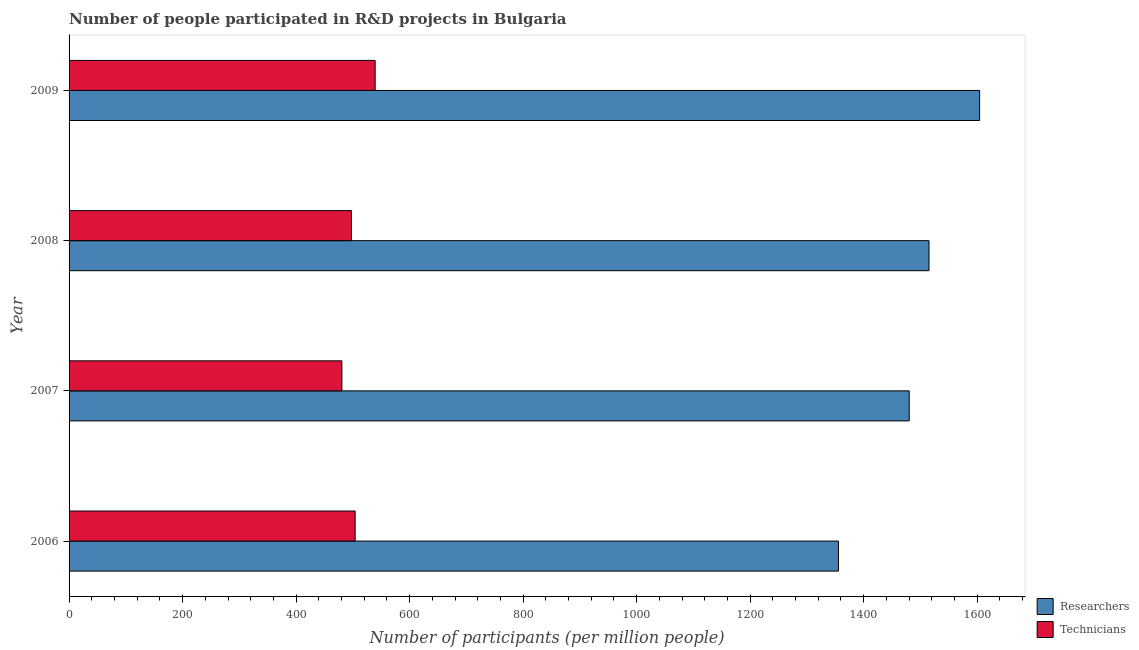Are the number of bars on each tick of the Y-axis equal?
Provide a succinct answer. Yes. How many bars are there on the 3rd tick from the bottom?
Provide a succinct answer. 2. In how many cases, is the number of bars for a given year not equal to the number of legend labels?
Your answer should be very brief. 0. What is the number of researchers in 2009?
Give a very brief answer. 1604.28. Across all years, what is the maximum number of technicians?
Ensure brevity in your answer.  539.27. Across all years, what is the minimum number of researchers?
Make the answer very short. 1355.61. In which year was the number of technicians minimum?
Provide a succinct answer. 2007. What is the total number of researchers in the graph?
Give a very brief answer. 5955.24. What is the difference between the number of technicians in 2006 and that in 2007?
Your answer should be very brief. 23.34. What is the difference between the number of researchers in 2009 and the number of technicians in 2008?
Offer a very short reply. 1106.78. What is the average number of technicians per year?
Ensure brevity in your answer.  505.37. In the year 2007, what is the difference between the number of technicians and number of researchers?
Your response must be concise. -999.55. In how many years, is the number of researchers greater than 400 ?
Keep it short and to the point. 4. What is the ratio of the number of researchers in 2006 to that in 2009?
Your answer should be very brief. 0.84. Is the number of technicians in 2006 less than that in 2007?
Provide a succinct answer. No. What is the difference between the highest and the second highest number of technicians?
Your response must be concise. 35.25. What is the difference between the highest and the lowest number of technicians?
Your answer should be very brief. 58.59. What does the 2nd bar from the top in 2006 represents?
Make the answer very short. Researchers. What does the 2nd bar from the bottom in 2007 represents?
Give a very brief answer. Technicians. Are all the bars in the graph horizontal?
Provide a short and direct response. Yes. How many years are there in the graph?
Keep it short and to the point. 4. Does the graph contain grids?
Your answer should be very brief. No. How many legend labels are there?
Your response must be concise. 2. What is the title of the graph?
Offer a very short reply. Number of people participated in R&D projects in Bulgaria. Does "2012 US$" appear as one of the legend labels in the graph?
Provide a succinct answer. No. What is the label or title of the X-axis?
Give a very brief answer. Number of participants (per million people). What is the label or title of the Y-axis?
Provide a succinct answer. Year. What is the Number of participants (per million people) of Researchers in 2006?
Ensure brevity in your answer.  1355.61. What is the Number of participants (per million people) of Technicians in 2006?
Your response must be concise. 504.03. What is the Number of participants (per million people) in Researchers in 2007?
Provide a short and direct response. 1480.24. What is the Number of participants (per million people) in Technicians in 2007?
Offer a very short reply. 480.68. What is the Number of participants (per million people) of Researchers in 2008?
Offer a very short reply. 1515.11. What is the Number of participants (per million people) of Technicians in 2008?
Provide a succinct answer. 497.49. What is the Number of participants (per million people) of Researchers in 2009?
Make the answer very short. 1604.28. What is the Number of participants (per million people) of Technicians in 2009?
Ensure brevity in your answer.  539.27. Across all years, what is the maximum Number of participants (per million people) in Researchers?
Ensure brevity in your answer.  1604.28. Across all years, what is the maximum Number of participants (per million people) in Technicians?
Keep it short and to the point. 539.27. Across all years, what is the minimum Number of participants (per million people) of Researchers?
Give a very brief answer. 1355.61. Across all years, what is the minimum Number of participants (per million people) in Technicians?
Make the answer very short. 480.68. What is the total Number of participants (per million people) of Researchers in the graph?
Give a very brief answer. 5955.24. What is the total Number of participants (per million people) of Technicians in the graph?
Offer a very short reply. 2021.48. What is the difference between the Number of participants (per million people) in Researchers in 2006 and that in 2007?
Ensure brevity in your answer.  -124.63. What is the difference between the Number of participants (per million people) in Technicians in 2006 and that in 2007?
Give a very brief answer. 23.34. What is the difference between the Number of participants (per million people) in Researchers in 2006 and that in 2008?
Give a very brief answer. -159.5. What is the difference between the Number of participants (per million people) of Technicians in 2006 and that in 2008?
Provide a succinct answer. 6.53. What is the difference between the Number of participants (per million people) of Researchers in 2006 and that in 2009?
Your response must be concise. -248.67. What is the difference between the Number of participants (per million people) in Technicians in 2006 and that in 2009?
Your response must be concise. -35.25. What is the difference between the Number of participants (per million people) in Researchers in 2007 and that in 2008?
Provide a short and direct response. -34.87. What is the difference between the Number of participants (per million people) of Technicians in 2007 and that in 2008?
Ensure brevity in your answer.  -16.81. What is the difference between the Number of participants (per million people) in Researchers in 2007 and that in 2009?
Keep it short and to the point. -124.04. What is the difference between the Number of participants (per million people) of Technicians in 2007 and that in 2009?
Provide a short and direct response. -58.59. What is the difference between the Number of participants (per million people) in Researchers in 2008 and that in 2009?
Offer a very short reply. -89.17. What is the difference between the Number of participants (per million people) of Technicians in 2008 and that in 2009?
Your answer should be compact. -41.78. What is the difference between the Number of participants (per million people) in Researchers in 2006 and the Number of participants (per million people) in Technicians in 2007?
Your response must be concise. 874.93. What is the difference between the Number of participants (per million people) in Researchers in 2006 and the Number of participants (per million people) in Technicians in 2008?
Offer a terse response. 858.12. What is the difference between the Number of participants (per million people) in Researchers in 2006 and the Number of participants (per million people) in Technicians in 2009?
Give a very brief answer. 816.34. What is the difference between the Number of participants (per million people) in Researchers in 2007 and the Number of participants (per million people) in Technicians in 2008?
Your answer should be very brief. 982.74. What is the difference between the Number of participants (per million people) in Researchers in 2007 and the Number of participants (per million people) in Technicians in 2009?
Provide a succinct answer. 940.97. What is the difference between the Number of participants (per million people) of Researchers in 2008 and the Number of participants (per million people) of Technicians in 2009?
Offer a very short reply. 975.84. What is the average Number of participants (per million people) of Researchers per year?
Your response must be concise. 1488.81. What is the average Number of participants (per million people) of Technicians per year?
Your answer should be compact. 505.37. In the year 2006, what is the difference between the Number of participants (per million people) in Researchers and Number of participants (per million people) in Technicians?
Offer a very short reply. 851.58. In the year 2007, what is the difference between the Number of participants (per million people) in Researchers and Number of participants (per million people) in Technicians?
Offer a terse response. 999.55. In the year 2008, what is the difference between the Number of participants (per million people) in Researchers and Number of participants (per million people) in Technicians?
Offer a very short reply. 1017.62. In the year 2009, what is the difference between the Number of participants (per million people) of Researchers and Number of participants (per million people) of Technicians?
Provide a succinct answer. 1065.01. What is the ratio of the Number of participants (per million people) in Researchers in 2006 to that in 2007?
Give a very brief answer. 0.92. What is the ratio of the Number of participants (per million people) of Technicians in 2006 to that in 2007?
Your answer should be very brief. 1.05. What is the ratio of the Number of participants (per million people) of Researchers in 2006 to that in 2008?
Offer a very short reply. 0.89. What is the ratio of the Number of participants (per million people) of Technicians in 2006 to that in 2008?
Your response must be concise. 1.01. What is the ratio of the Number of participants (per million people) of Researchers in 2006 to that in 2009?
Ensure brevity in your answer.  0.84. What is the ratio of the Number of participants (per million people) of Technicians in 2006 to that in 2009?
Your answer should be compact. 0.93. What is the ratio of the Number of participants (per million people) in Technicians in 2007 to that in 2008?
Provide a short and direct response. 0.97. What is the ratio of the Number of participants (per million people) of Researchers in 2007 to that in 2009?
Your answer should be very brief. 0.92. What is the ratio of the Number of participants (per million people) in Technicians in 2007 to that in 2009?
Give a very brief answer. 0.89. What is the ratio of the Number of participants (per million people) of Researchers in 2008 to that in 2009?
Offer a very short reply. 0.94. What is the ratio of the Number of participants (per million people) in Technicians in 2008 to that in 2009?
Provide a short and direct response. 0.92. What is the difference between the highest and the second highest Number of participants (per million people) of Researchers?
Offer a terse response. 89.17. What is the difference between the highest and the second highest Number of participants (per million people) of Technicians?
Give a very brief answer. 35.25. What is the difference between the highest and the lowest Number of participants (per million people) of Researchers?
Offer a very short reply. 248.67. What is the difference between the highest and the lowest Number of participants (per million people) in Technicians?
Offer a terse response. 58.59. 